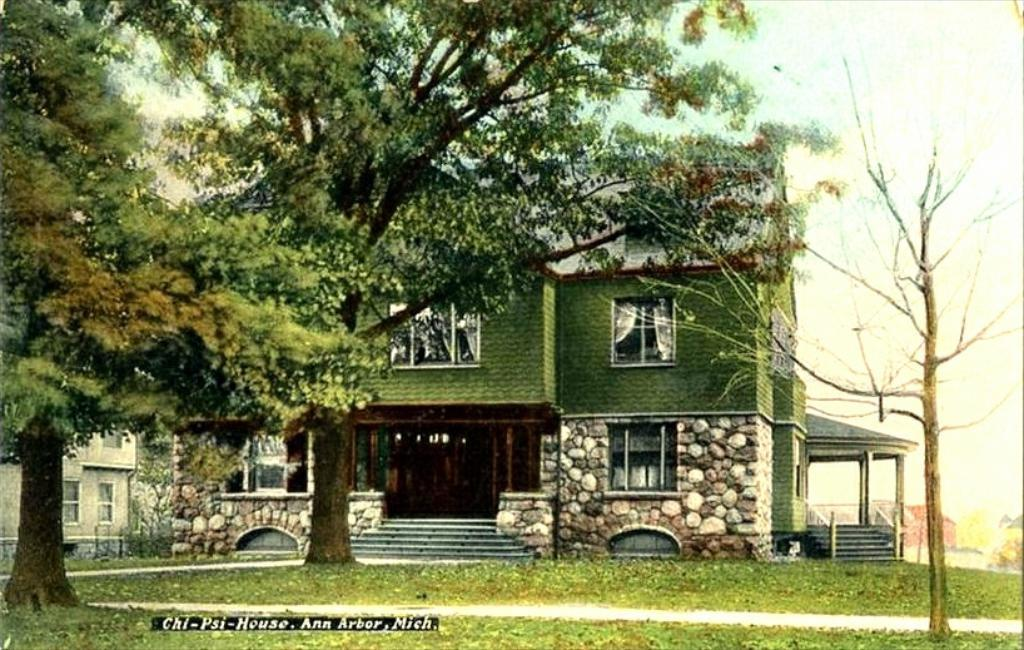What type of structures can be seen in the image? There are houses in the image. What type of vegetation is present in the image? There is grass and trees in the image. What can be seen in the background of the image? The sky is visible in the background of the image. Is there any indication of ownership or origin on the image? Yes, there is a watermark on the image. What type of bead is used to decorate the houses in the image? There are no beads present in the image, and the houses are not decorated with any beads. Can you see a quill being used by someone in the image? There is no quill or any indication of writing in the image. 